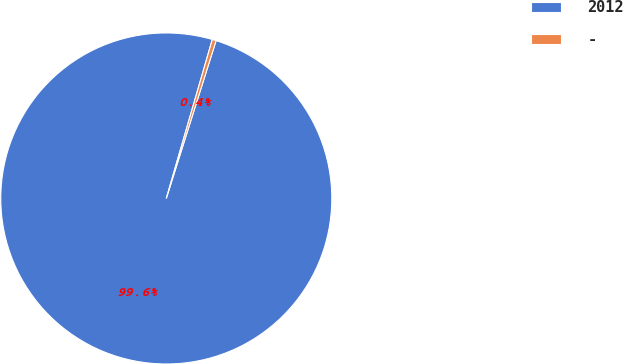<chart> <loc_0><loc_0><loc_500><loc_500><pie_chart><fcel>2012<fcel>-<nl><fcel>99.62%<fcel>0.38%<nl></chart> 